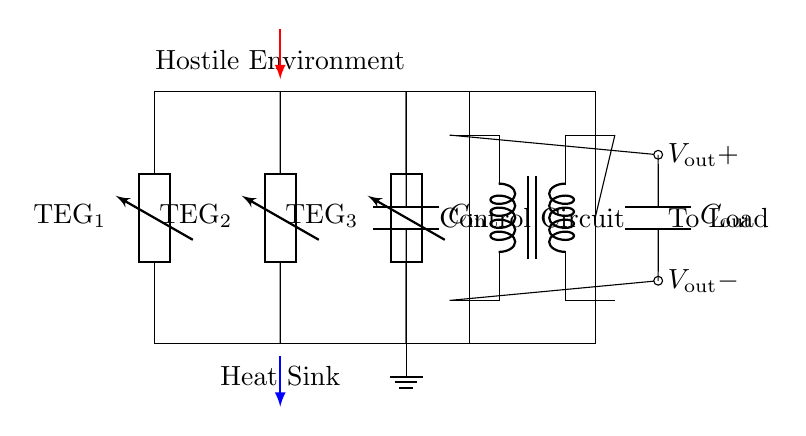What type of components are represented in the circuit? The components in the circuit include thermoelectric generators, capacitors, a control circuit, and a DC-DC converter. Each type of component serves a specific function in energy harvesting and management within the circuit.
Answer: thermoelectric generators, capacitors, control circuit, DC-DC converter How many thermoelectric generators are present? The circuit diagram shows three thermoelectric generators connected in parallel. You can count the instances of the 'TEG' label in the circuit to verify this.
Answer: three What is the function of the control circuit? The control circuit manages the output voltage and optimizes the system's operation according to environmental conditions. It stabilizes and controls the energy harvested from the thermoelectric generators before sending it to the load.
Answer: manage output voltage What is the role of capacitors in this circuit? The capacitors function to stabilize the voltage and store electrical energy for both input and output. The input capacitor smooths the current from the thermoelectric generators, while the output capacitor ensures a steady voltage to the load.
Answer: stabilize voltage, store energy What happens to the thermal energy when it reaches the thermoelectric generators? The thermal energy causes a temperature difference across the generators, which leads to the generation of electrical energy. This conversion process is essential for energy harvesting from thermal sources in hostile environments.
Answer: generates electrical energy What is the output voltage represented in the circuit? The output voltage in the circuit is denoted as V out, which refers to the voltage supplied to the load. It is the result of the operation of the DC-DC converter and depends on the configuration of the circuit and conditions of the thermoelectric generators.
Answer: V out 